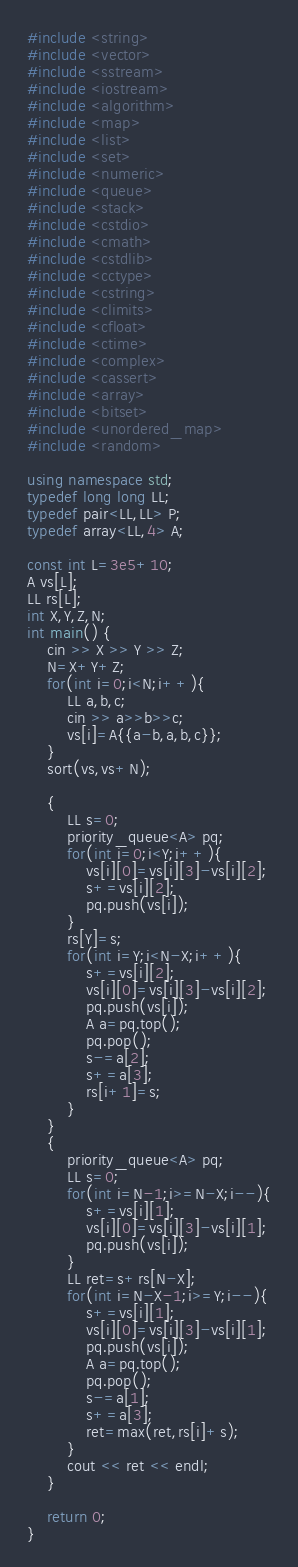<code> <loc_0><loc_0><loc_500><loc_500><_C++_>#include <string>
#include <vector>
#include <sstream>
#include <iostream>
#include <algorithm>
#include <map>
#include <list>
#include <set>
#include <numeric>
#include <queue>
#include <stack>
#include <cstdio>
#include <cmath>
#include <cstdlib>
#include <cctype>
#include <cstring>
#include <climits>
#include <cfloat>
#include <ctime>
#include <complex>
#include <cassert>
#include <array>
#include <bitset> 
#include <unordered_map>
#include <random>

using namespace std;
typedef long long LL;
typedef pair<LL,LL> P;
typedef array<LL,4> A;

const int L=3e5+10;
A vs[L];
LL rs[L];
int X,Y,Z,N;
int main() {
	cin >> X >> Y >> Z;
	N=X+Y+Z;
	for(int i=0;i<N;i++){
		LL a,b,c;
		cin >> a>>b>>c;
		vs[i]=A{{a-b,a,b,c}};
	}
	sort(vs,vs+N);

	{
		LL s=0;
		priority_queue<A> pq;
		for(int i=0;i<Y;i++){
			vs[i][0]=vs[i][3]-vs[i][2];
			s+=vs[i][2];
			pq.push(vs[i]);
		}
		rs[Y]=s;
		for(int i=Y;i<N-X;i++){
			s+=vs[i][2];
			vs[i][0]=vs[i][3]-vs[i][2];
			pq.push(vs[i]);
			A a=pq.top();
			pq.pop();
			s-=a[2];
			s+=a[3];
			rs[i+1]=s;
		}
	}
	{
		priority_queue<A> pq;
		LL s=0;
		for(int i=N-1;i>=N-X;i--){
			s+=vs[i][1];
			vs[i][0]=vs[i][3]-vs[i][1];
			pq.push(vs[i]);
		}
		LL ret=s+rs[N-X];
		for(int i=N-X-1;i>=Y;i--){
			s+=vs[i][1];
			vs[i][0]=vs[i][3]-vs[i][1];
			pq.push(vs[i]);
			A a=pq.top();
			pq.pop();
			s-=a[1];
			s+=a[3];
			ret=max(ret,rs[i]+s);
		}
		cout << ret << endl;
	}

	return 0;
}

</code> 